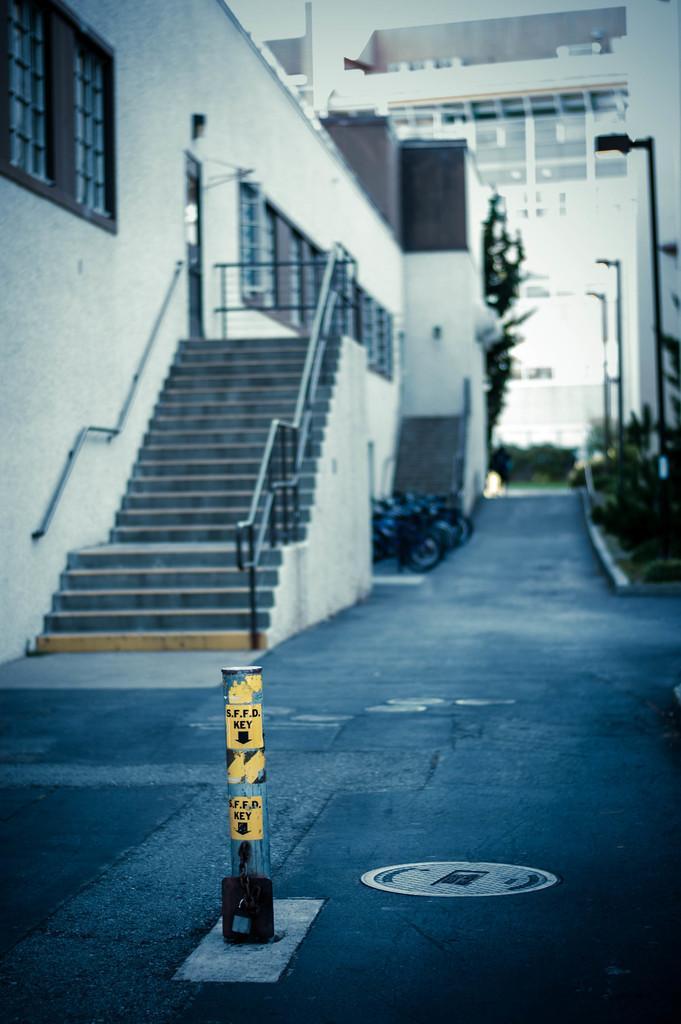Describe this image in one or two sentences. In this image we can see a building, rod, windows, staircase, bikes, plants, and poles. Here we can see a road. 